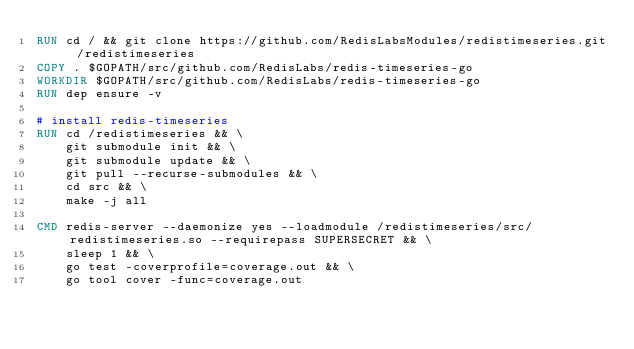<code> <loc_0><loc_0><loc_500><loc_500><_Dockerfile_>RUN cd / && git clone https://github.com/RedisLabsModules/redistimeseries.git /redistimeseries
COPY . $GOPATH/src/github.com/RedisLabs/redis-timeseries-go
WORKDIR $GOPATH/src/github.com/RedisLabs/redis-timeseries-go
RUN dep ensure -v

# install redis-timeseries
RUN cd /redistimeseries && \
    git submodule init && \
    git submodule update && \
    git pull --recurse-submodules && \
    cd src && \
    make -j all

CMD redis-server --daemonize yes --loadmodule /redistimeseries/src/redistimeseries.so --requirepass SUPERSECRET && \
    sleep 1 && \
    go test -coverprofile=coverage.out && \
    go tool cover -func=coverage.out
</code> 